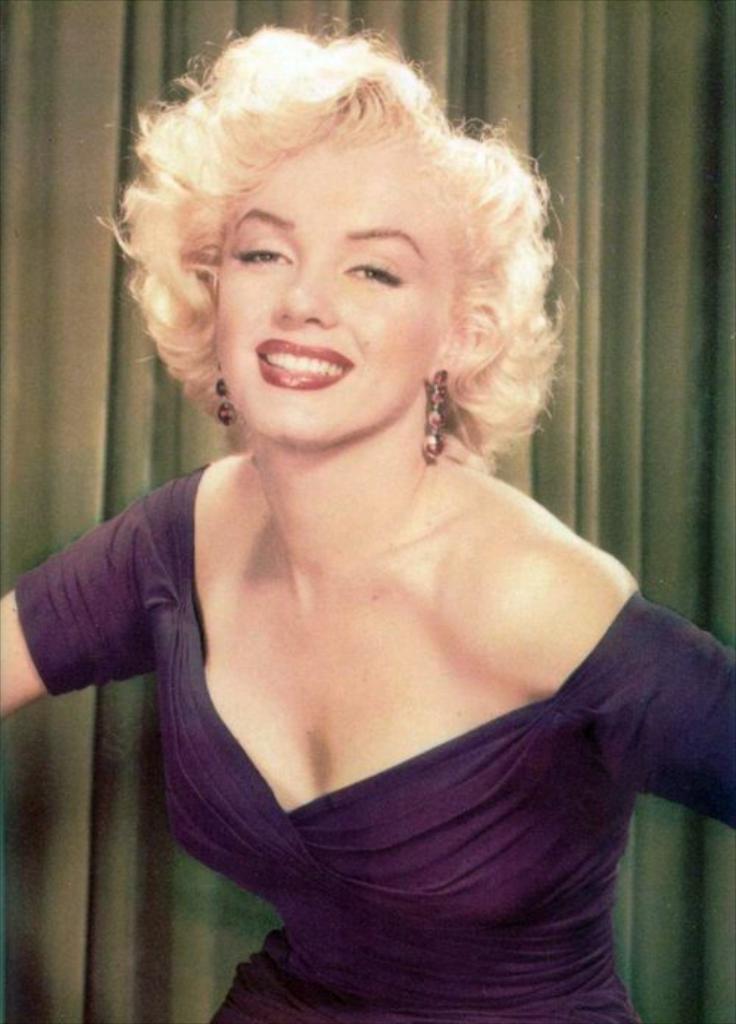How would you summarize this image in a sentence or two? In this image, we can see a woman is watching and smiling. Background we can see curtain. 